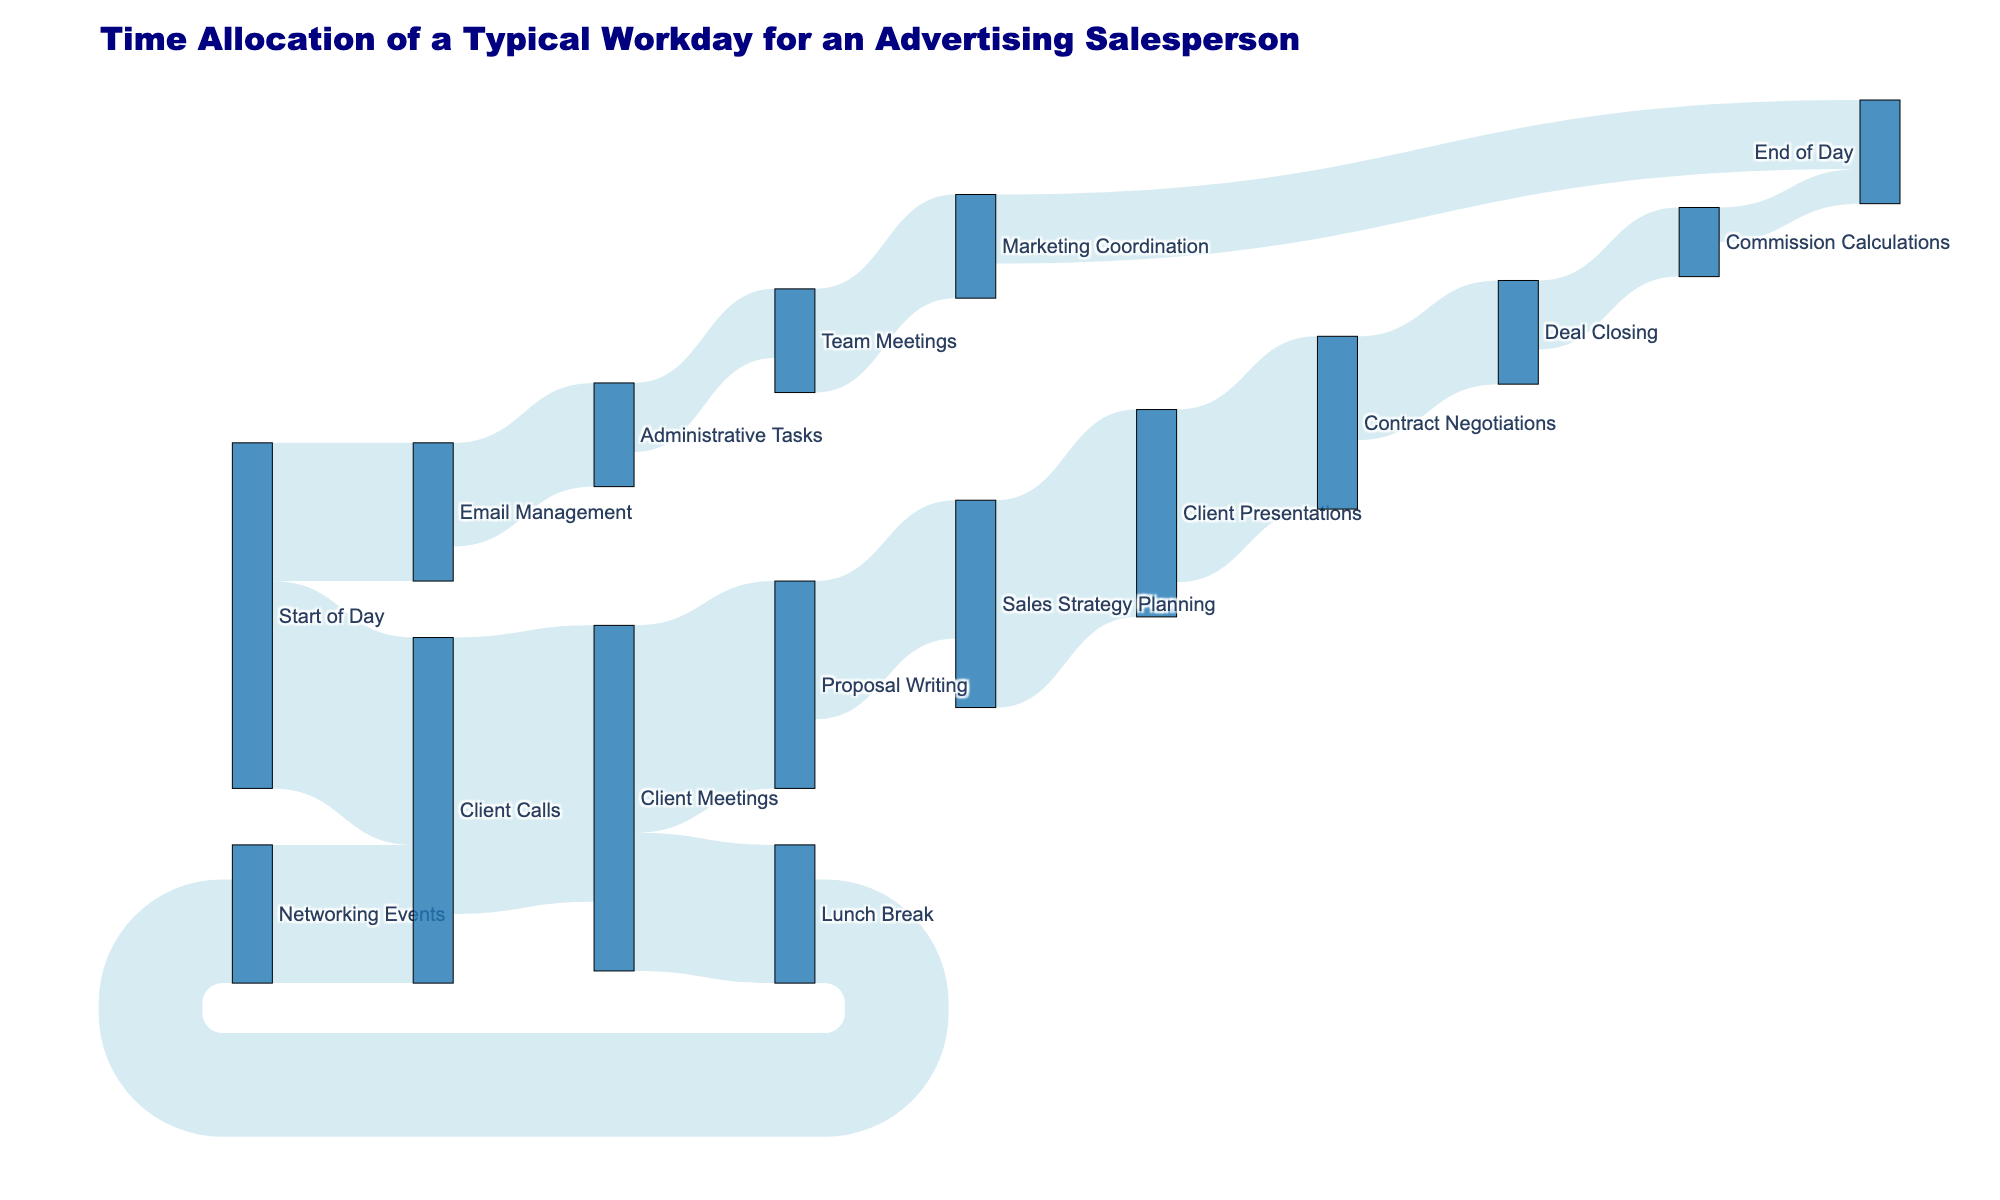what is the title of the chart? Look at the top part of the figure where the title is usually displayed in bold or larger text.
Answer: Time Allocation of a Typical Workday for an Advertising Salesperson Which task takes the longest time starting from 'Start of Day'? Identify the flow from 'Start of Day' with the largest value.
Answer: Client Calls How much time is spent on 'Proposal Writing'? Locate the flow labeled 'Proposal Writing' and sum up the time allocated to it.
Answer: 90 minutes What activities follow 'Email Management'? Observe the flows originating from 'Email Management'.
Answer: Administrative Tasks Which activity does 'Deal Closing' directly lead to? Look for the target node connected from 'Deal Closing'.
Answer: Commission Calculations How much time is allocated to 'Client Meetings' in total? Add up all time values leading to and from 'Client Meetings'.
Answer: 120 minutes from Client Calls and 60 minutes to Proposal Writing and 60 minutes to Lunch Break, totaling 240 minutes What’s the next task after 'Sales Strategy Planning'? Trace the flow coming out from 'Sales Strategy Planning'.
Answer: Client Presentations From 'Networking Events', where does the salesperson go next? Follow the flow from 'Networking Events'.
Answer: Client Calls How much time does the salesperson spend from 'Client Calls' to 'Client Meetings'? Find the value for the flow from 'Client Calls' to 'Client Meetings'.
Answer: 120 minutes Which tasks contribute to the 'End of Day'? Identify all incoming flows to 'End of Day'.
Answer: Marketing Coordination and Commission Calculations 